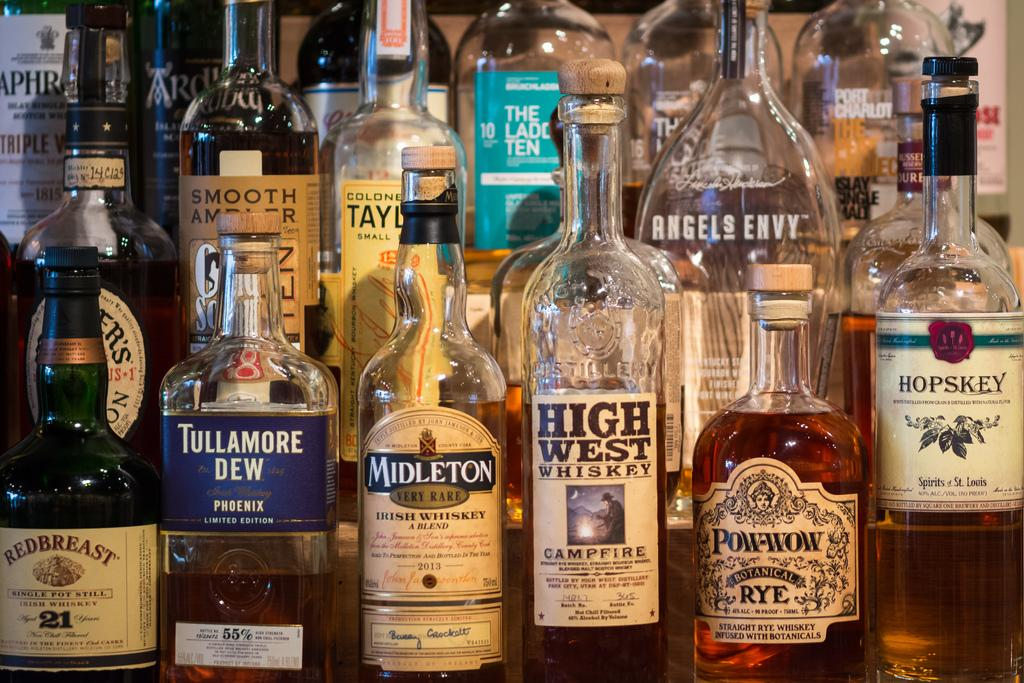<image>
Write a terse but informative summary of the picture. Various bottles of alcohol like High West Whiskey 